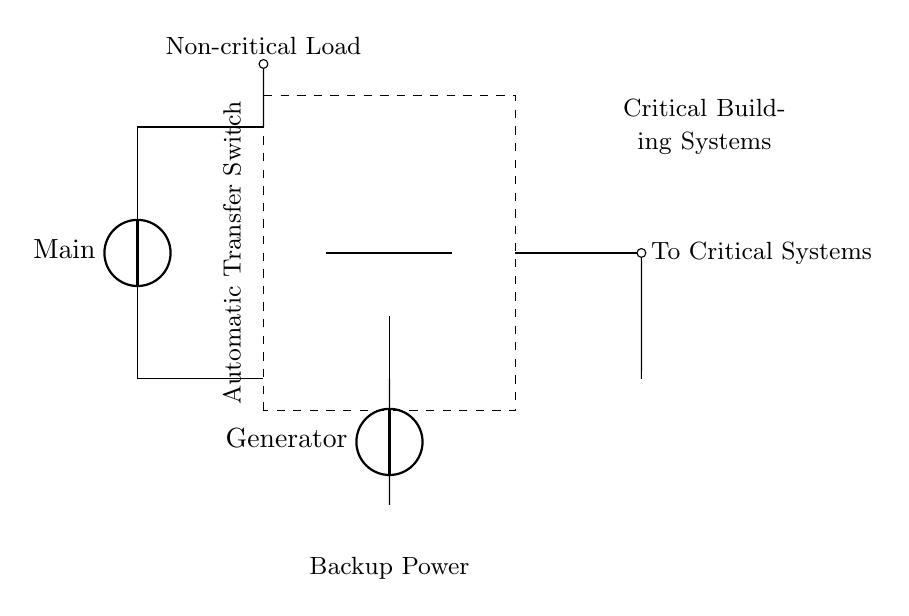What is the main source of power in this circuit? The main source of power is indicated as Main in the diagram, which is a voltage source connected at the top left of the circuit.
Answer: Main What is the function of the Automatic Transfer Switch? The function of the Automatic Transfer Switch is to switch between the main power source and the generator, ensuring that critical systems remain powered during an outage.
Answer: Switching How many inputs does the Automatic Transfer Switch have? The Automatic Transfer Switch has two inputs: one from the Main power and one from the Generator power source.
Answer: Two Which loads are connected to the Backup Power circuit? The loads include a Non-critical Load connected to the Main, while critical systems are connected to the output of the Automatic Transfer Switch.
Answer: Non-critical Load and critical systems What happens to critical systems during a power outage? During a power outage, the Automatic Transfer Switch automatically connects the Generator to the critical systems, maintaining power supply.
Answer: Maintained power What is the purpose of the dashed lines in the circuit? The dashed lines indicate the enclosure of the Automatic Transfer Switch, distinguishing it from the other components in the circuit.
Answer: Enclosure indication How is the generator represented in this circuit? The generator is represented as a voltage source labeled "Generator" connected at the bottom left, indicating its function in providing backup power.
Answer: Voltage source labeled Generator 